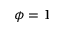Convert formula to latex. <formula><loc_0><loc_0><loc_500><loc_500>\phi = 1</formula> 